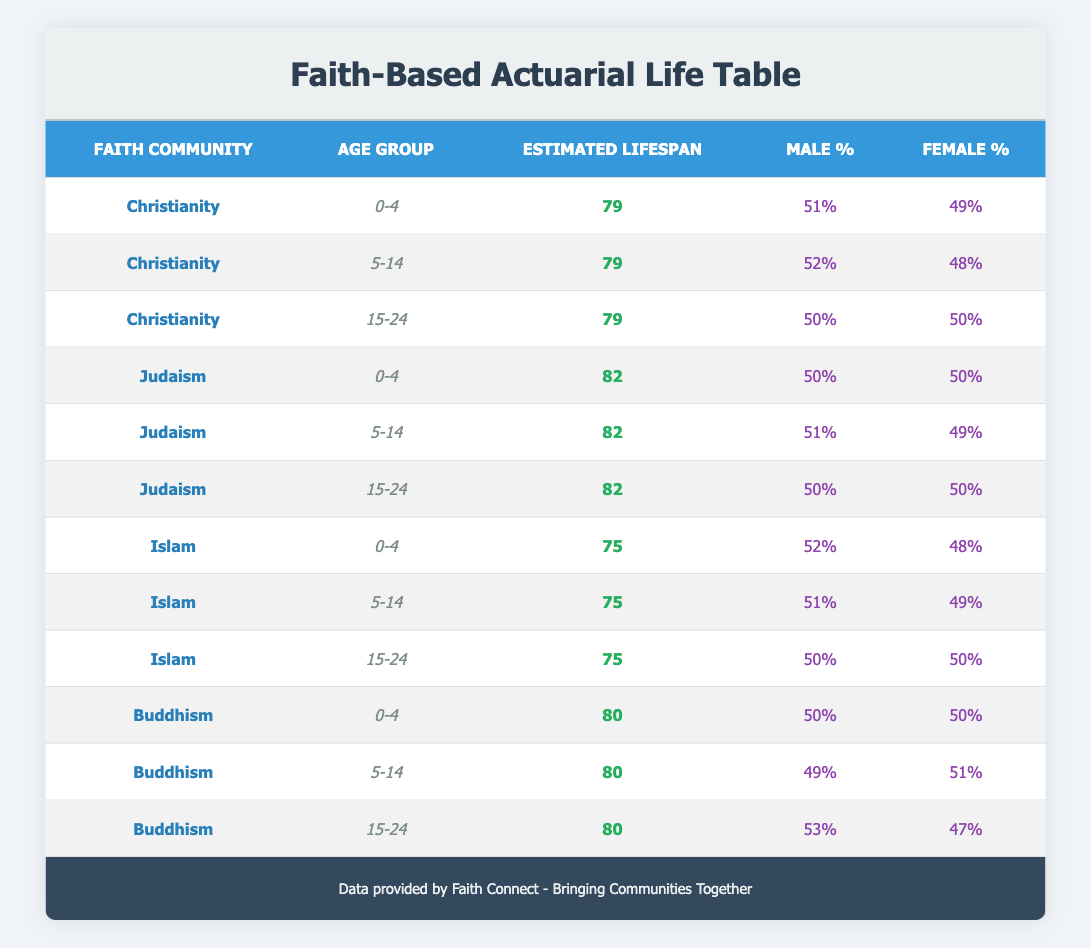What is the estimated lifespan for members of the Judaism community aged 0-4? The table indicates that for the Judaism community and the age group 0-4, the estimated lifespan is 82 years.
Answer: 82 What percentage of males is there in the Buddhism community aged 15-24? Referring to the Buddhism section for the age group 15-24, the table shows that the male percentage is 53%.
Answer: 53% Which faith community has the highest estimated lifespan for the age group 5-14? For the age group 5-14, the estimated lifespans are: Christianity 79, Judaism 82, Islam 75, and Buddhism 80. The highest among these is 82 for Judaism.
Answer: Judaism Is the male percentage in the Christianity community higher than that in the Islam community for the age group 0-4? Christianity has a male percentage of 51% for the age group 0-4, while Islam has 52%. Since 51% is less than 52%, the statement is false.
Answer: No What is the average estimated lifespan for the age group 0-4 across all faith communities listed? The estimated lifespans for the age group 0-4 are: Christianity 79, Judaism 82, Islam 75, and Buddhism 80. The average is calculated as (79 + 82 + 75 + 80) / 4 = 79. The sum is 316, and dividing by 4 gives an average of 79.
Answer: 79 Does the Buddhism community have a higher female percentage than the Christianity community for the age group 5-14? Buddhism has a female percentage of 51% while Christianity has 48%. Since 51% is more than 48%, the statement is true.
Answer: Yes What is the difference in estimated lifespan between the Judaism and Islam communities for the age group 5-14? The estimated lifespan for Judaism at that age is 82, while for Islam it's 75. Thus, the difference is 82 - 75 = 7 years.
Answer: 7 Which age group has the same estimated lifespan across all listed faith communities for Christianity? The table indicates that the estimated lifespan for Christianity is consistent at 79 across all listed age groups (0-4, 5-14, and 15-24).
Answer: All age groups 